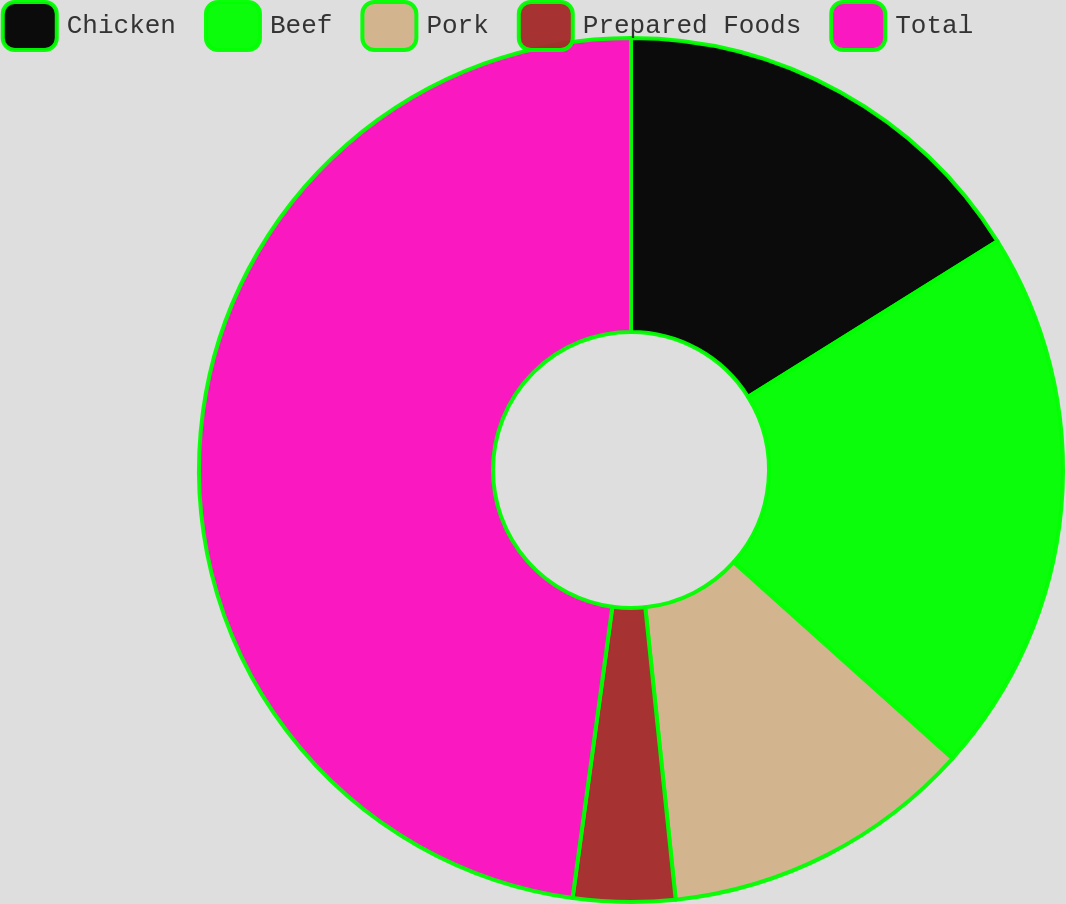Convert chart. <chart><loc_0><loc_0><loc_500><loc_500><pie_chart><fcel>Chicken<fcel>Beef<fcel>Pork<fcel>Prepared Foods<fcel>Total<nl><fcel>16.12%<fcel>20.52%<fcel>11.71%<fcel>3.81%<fcel>47.84%<nl></chart> 